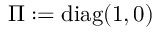Convert formula to latex. <formula><loc_0><loc_0><loc_500><loc_500>\Pi \colon = d i a g ( 1 , 0 )</formula> 